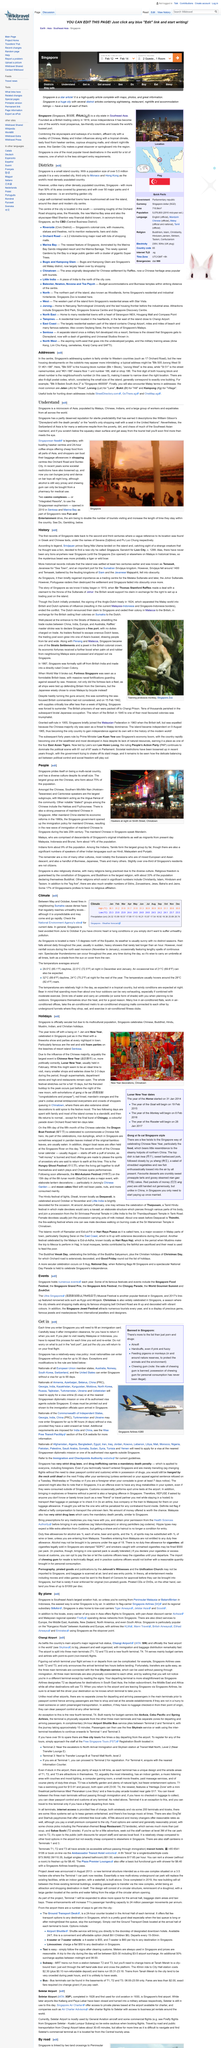Give some essential details in this illustration. In Singapore, over 75% of the population is of Chinese descent. China began its economic reforms in the 1980s, marking a significant shift in the country's economic policies and paving the way for its rapid growth and development in the following decades. Smith Street is visible in the photograph. 